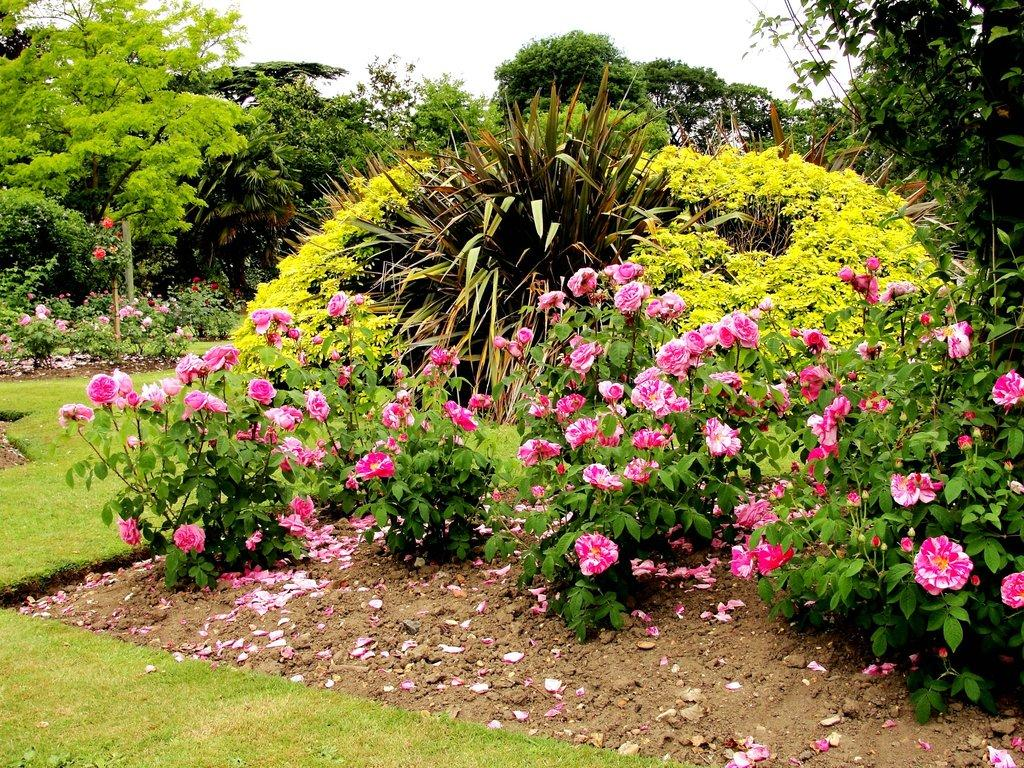What can be seen on the plants in the image? There are many flowers on the plants in the image. What is visible in the background of the image? There are trees, plants, and grass in the background of the image. What is visible at the top of the image? The sky is visible at the top of the image. What type of animal can be seen walking on the street in the image? There is no street or animal present in the image; it features flowers on plants, trees, plants, grass, and the sky. 